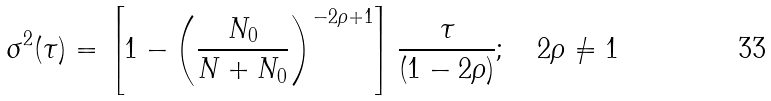Convert formula to latex. <formula><loc_0><loc_0><loc_500><loc_500>\sigma ^ { 2 } ( \tau ) = \left [ 1 - \left ( \frac { N _ { 0 } } { N + N _ { 0 } } \right ) ^ { - 2 \rho + 1 } \right ] \frac { \tau } { ( 1 - 2 \rho ) } ; \quad 2 \rho \neq 1</formula> 